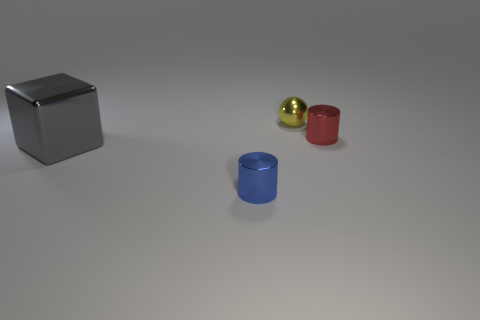How many metallic balls are to the right of the tiny thing behind the red metal cylinder?
Keep it short and to the point. 0. What size is the thing that is on the left side of the small metallic object to the left of the small yellow shiny object that is right of the big gray thing?
Offer a very short reply. Large. Is the color of the small metal cylinder to the left of the shiny sphere the same as the big object?
Make the answer very short. No. What size is the other metallic object that is the same shape as the small blue metal thing?
Ensure brevity in your answer.  Small. How many things are small metallic things that are in front of the red metal cylinder or tiny things that are on the left side of the small yellow metallic thing?
Your answer should be compact. 1. The shiny thing behind the metal cylinder that is behind the big gray cube is what shape?
Keep it short and to the point. Sphere. Are there any other things that have the same color as the big metallic object?
Provide a succinct answer. No. Are there any other things that have the same size as the red cylinder?
Make the answer very short. Yes. What number of things are tiny cylinders or tiny yellow spheres?
Your answer should be very brief. 3. Is there a blue object of the same size as the sphere?
Give a very brief answer. Yes. 